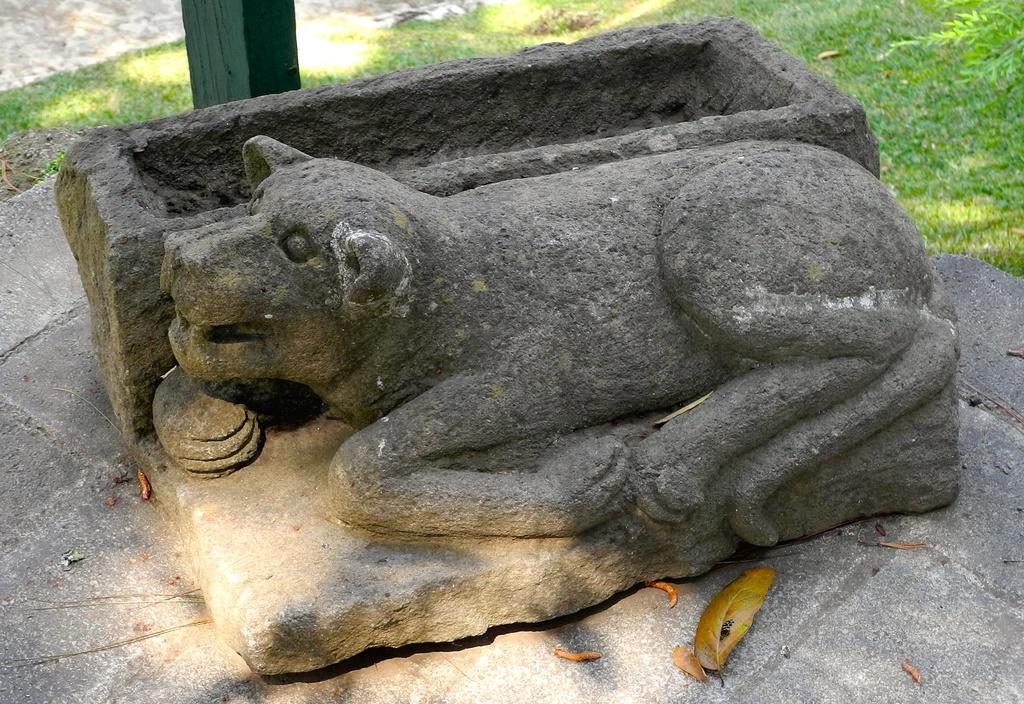What is located on the ground in the image? There is a sculpture on the ground in the image. What other object can be seen in the image? There is a pole in the image. What type of vegetation is visible in the background of the image? There is grass in the background of the image. Can you tell me how many kitties are playing with a quarter in the image? There are no kitties or quarters present in the image; it features a sculpture and a pole. What type of joke is being told by the sculpture in the image? There is no joke being told by the sculpture in the image; it is a stationary object. 